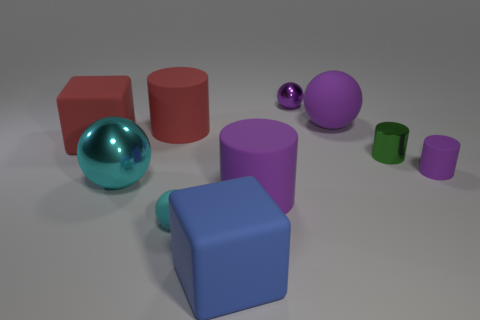Subtract all brown cylinders. Subtract all cyan cubes. How many cylinders are left? 4 Subtract all balls. How many objects are left? 6 Subtract 0 brown cylinders. How many objects are left? 10 Subtract all matte cubes. Subtract all tiny matte balls. How many objects are left? 7 Add 5 large blue objects. How many large blue objects are left? 6 Add 4 tiny matte cylinders. How many tiny matte cylinders exist? 5 